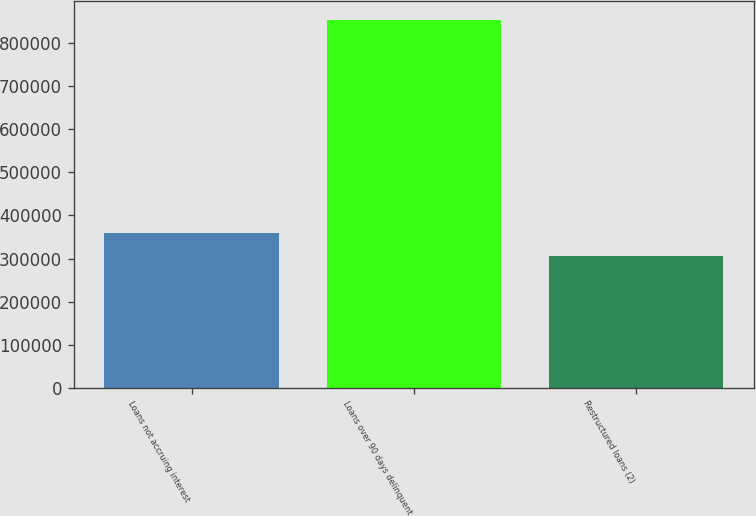Convert chart to OTSL. <chart><loc_0><loc_0><loc_500><loc_500><bar_chart><fcel>Loans not accruing interest<fcel>Loans over 90 days delinquent<fcel>Restructured loans (2)<nl><fcel>360185<fcel>853757<fcel>305344<nl></chart> 